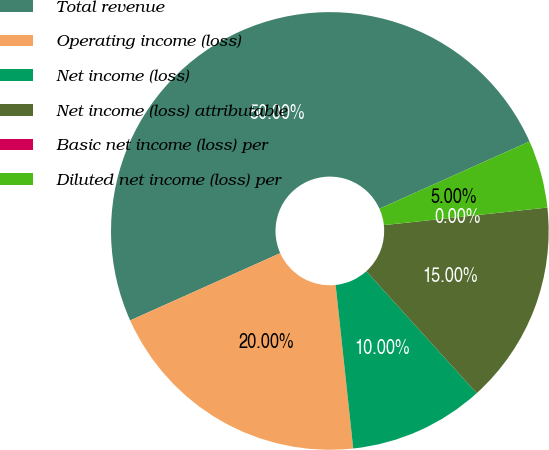Convert chart to OTSL. <chart><loc_0><loc_0><loc_500><loc_500><pie_chart><fcel>Total revenue<fcel>Operating income (loss)<fcel>Net income (loss)<fcel>Net income (loss) attributable<fcel>Basic net income (loss) per<fcel>Diluted net income (loss) per<nl><fcel>50.0%<fcel>20.0%<fcel>10.0%<fcel>15.0%<fcel>0.0%<fcel>5.0%<nl></chart> 